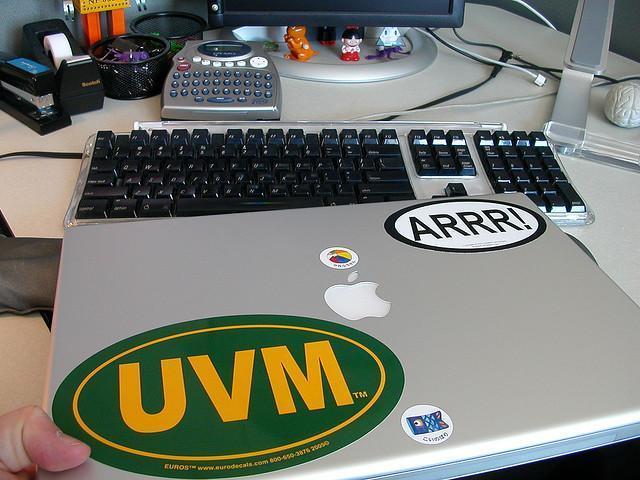How many fingers are seen?
Give a very brief answer. 1. How many keyboards are in the picture?
Give a very brief answer. 1. How many red chairs are in this image?
Give a very brief answer. 0. 